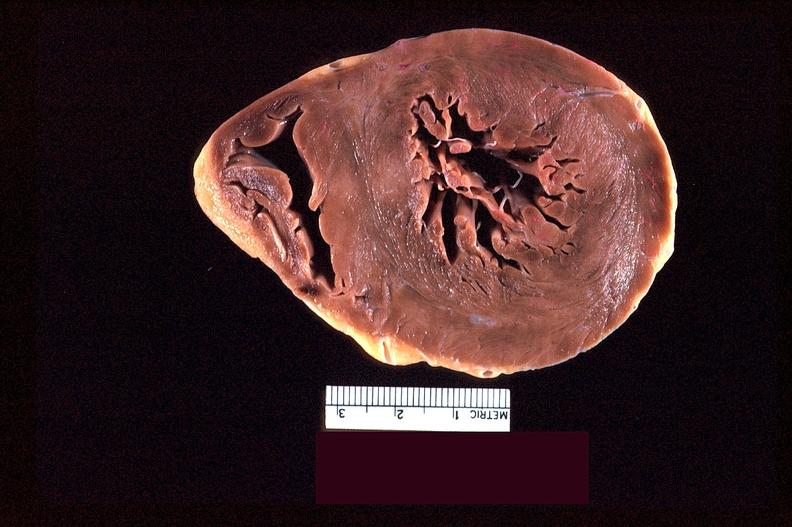s cardiovascular present?
Answer the question using a single word or phrase. Yes 